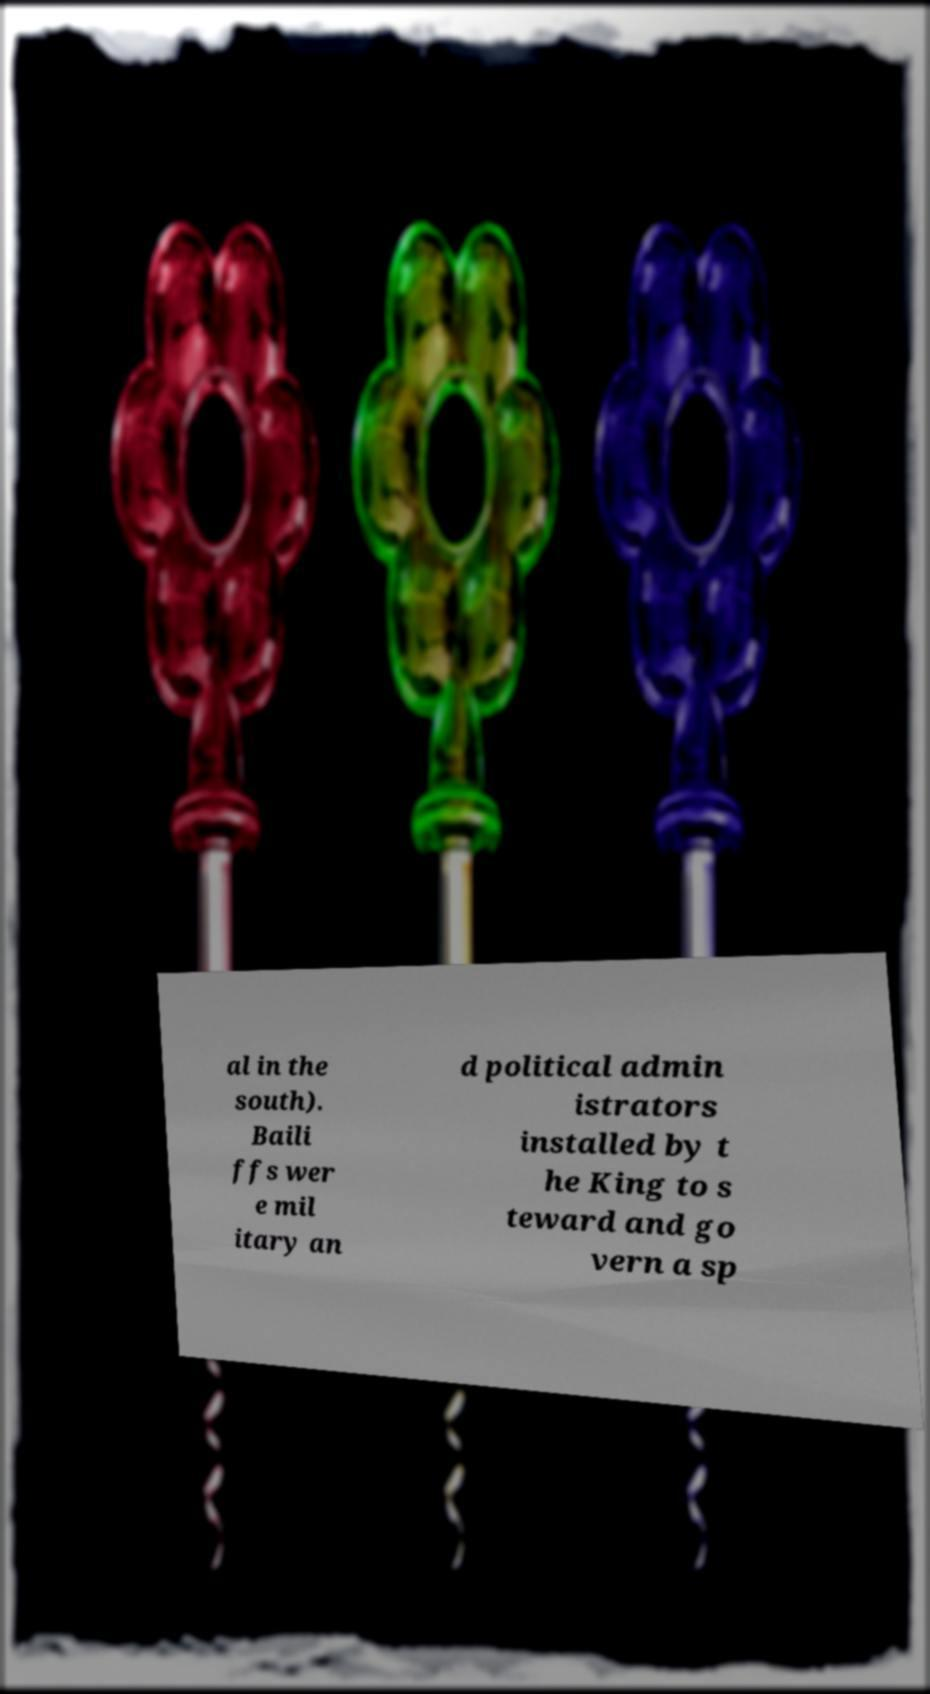Could you extract and type out the text from this image? al in the south). Baili ffs wer e mil itary an d political admin istrators installed by t he King to s teward and go vern a sp 